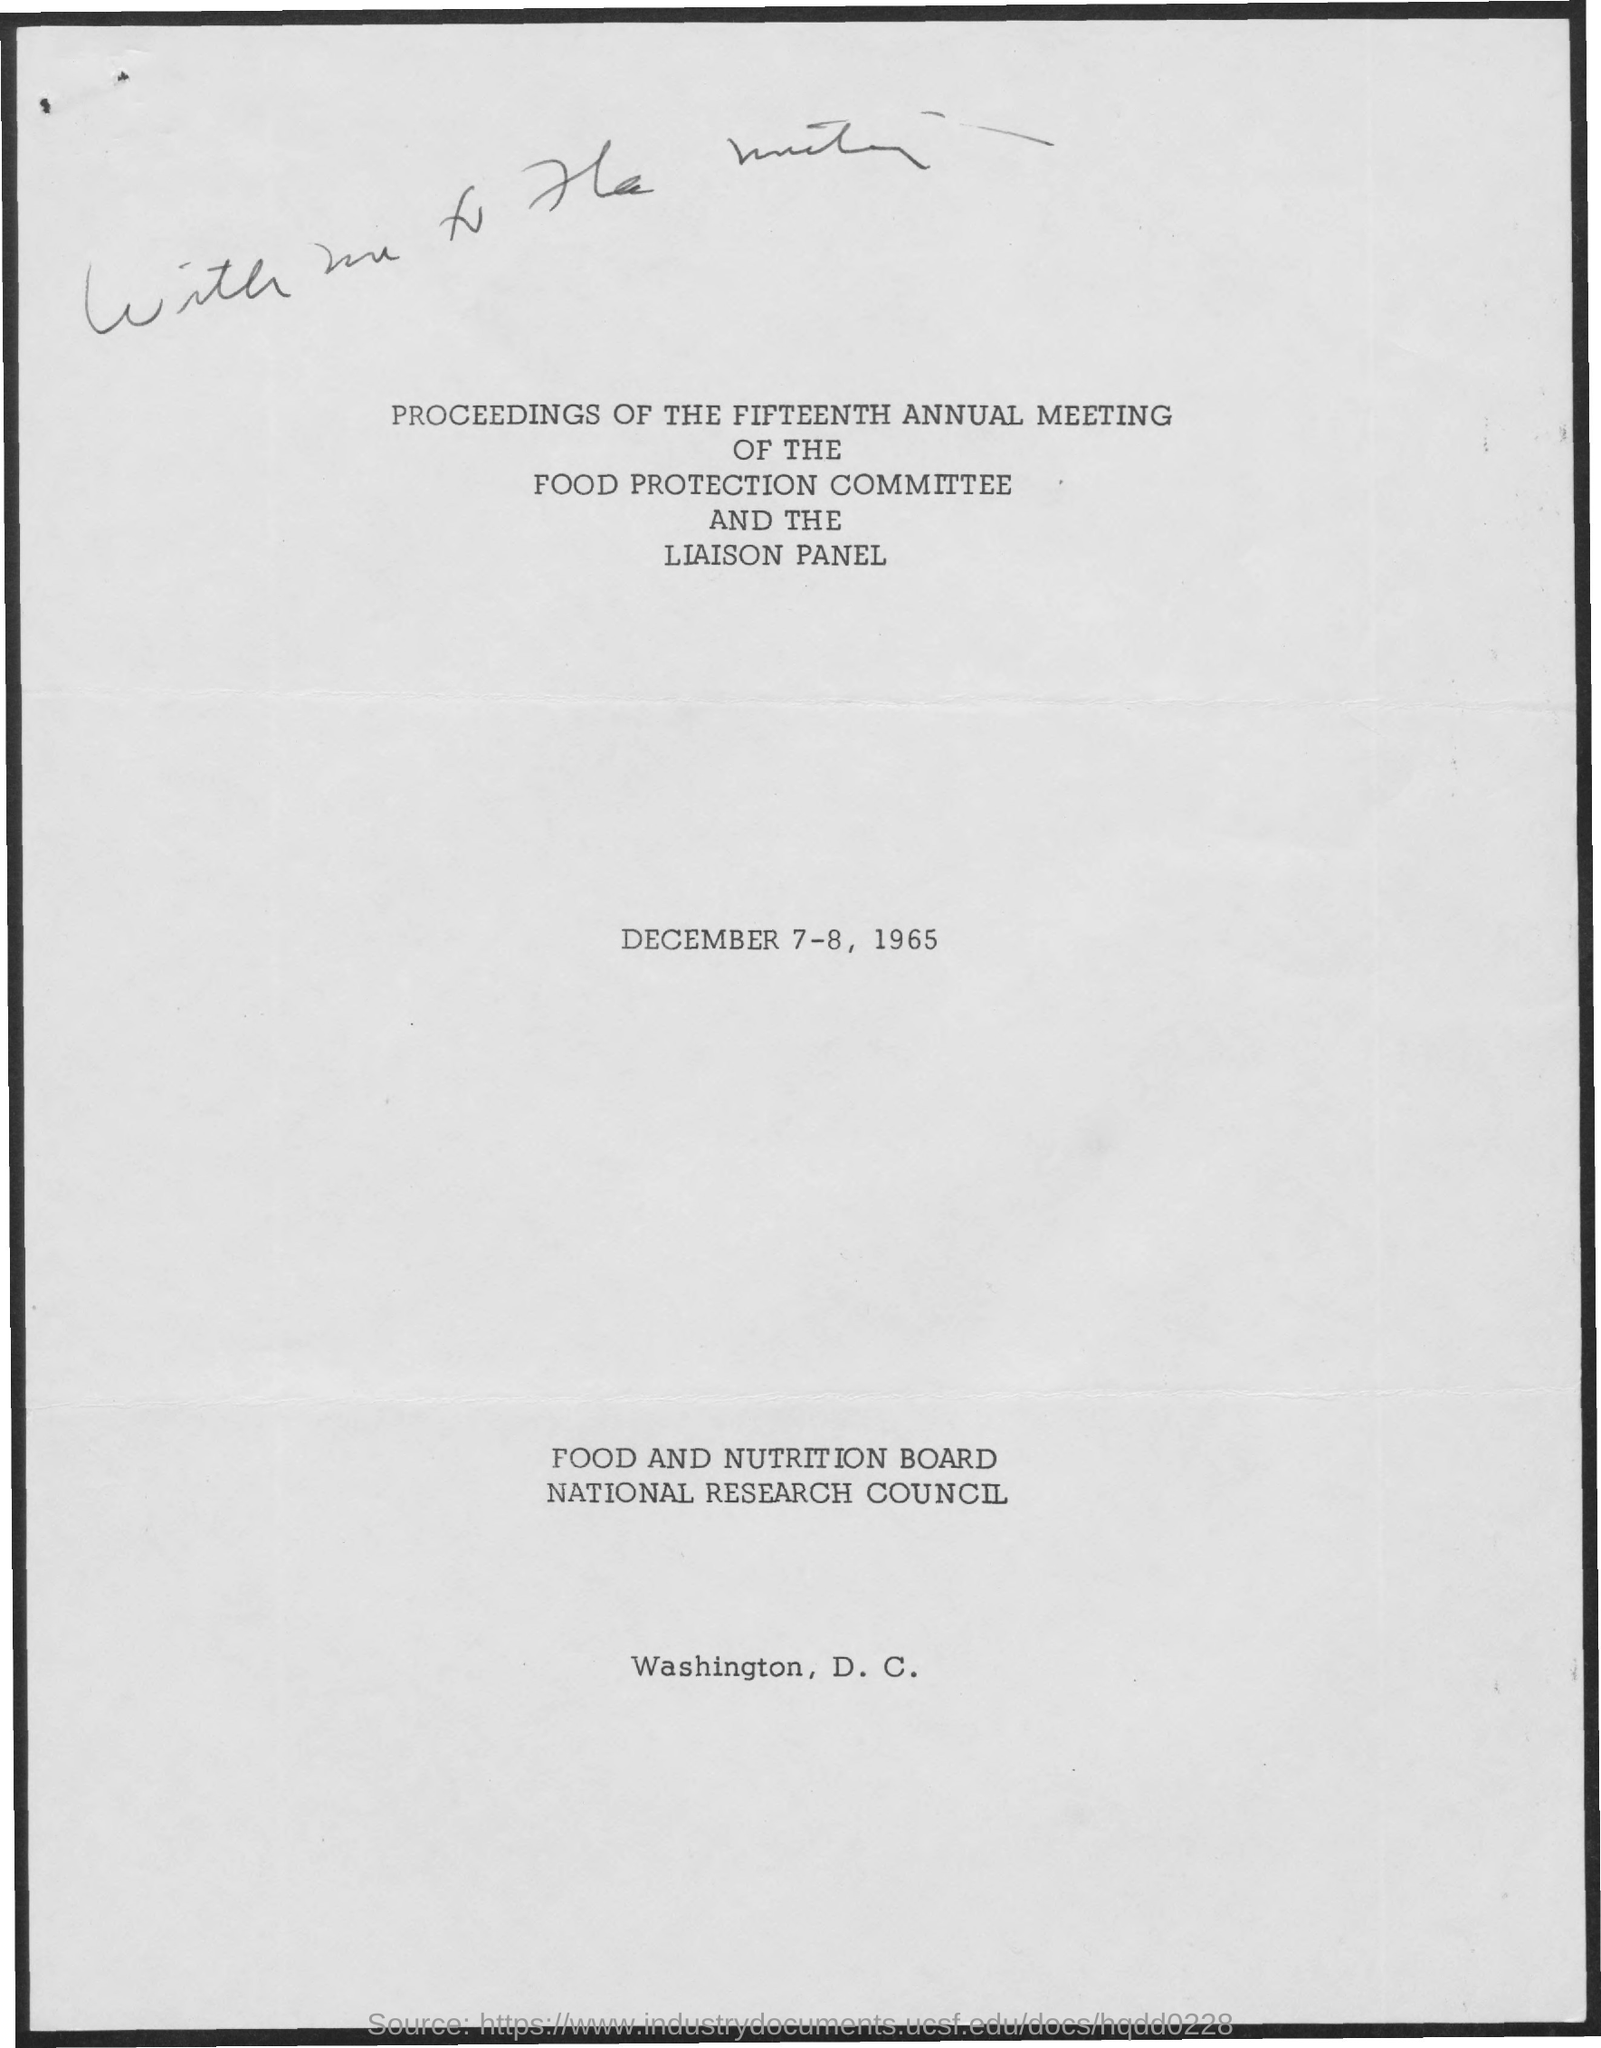What is the date mentioned in the document?
Give a very brief answer. December 7-8, 1965. 